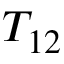<formula> <loc_0><loc_0><loc_500><loc_500>T _ { 1 2 }</formula> 